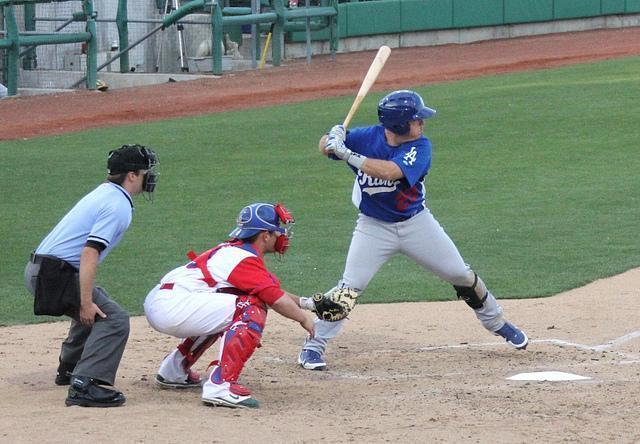What will the next thing the pitcher does?
Pick the correct solution from the four options below to address the question.
Options: Bat, eat lunch, pitch ball, take break. Pitch ball. 